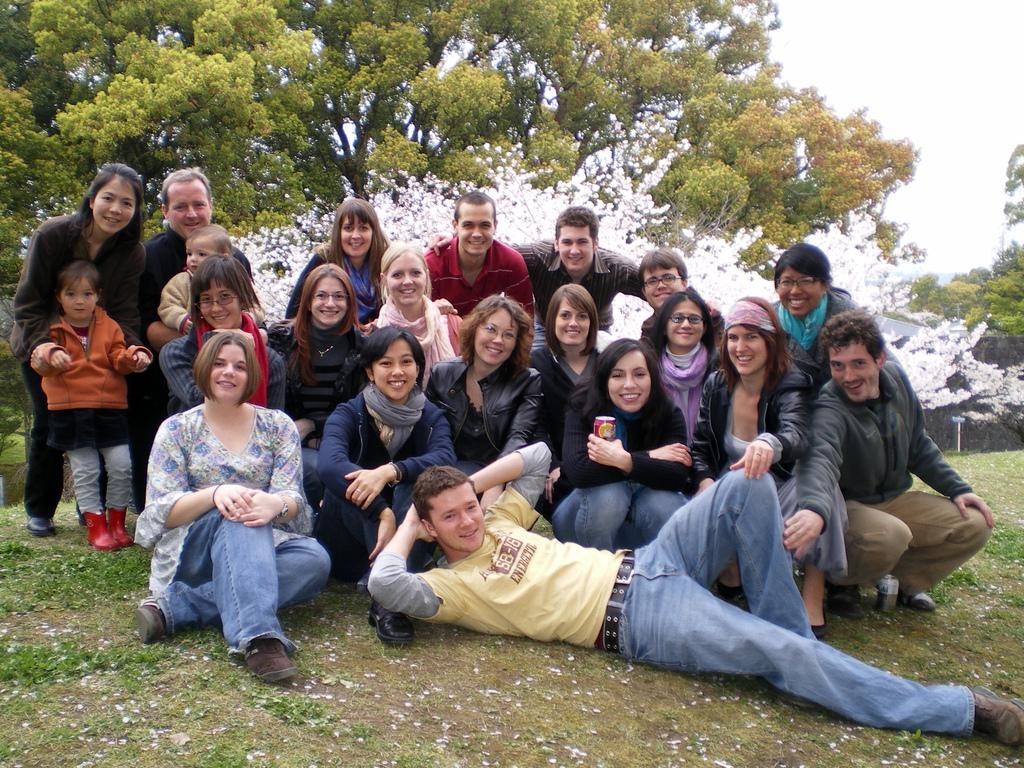How would you summarize this image in a sentence or two? In this image we can see few persons are sitting, a girl is standing, man is lying and few persons are in squat position on the ground. In the background we can see trees and sky. 